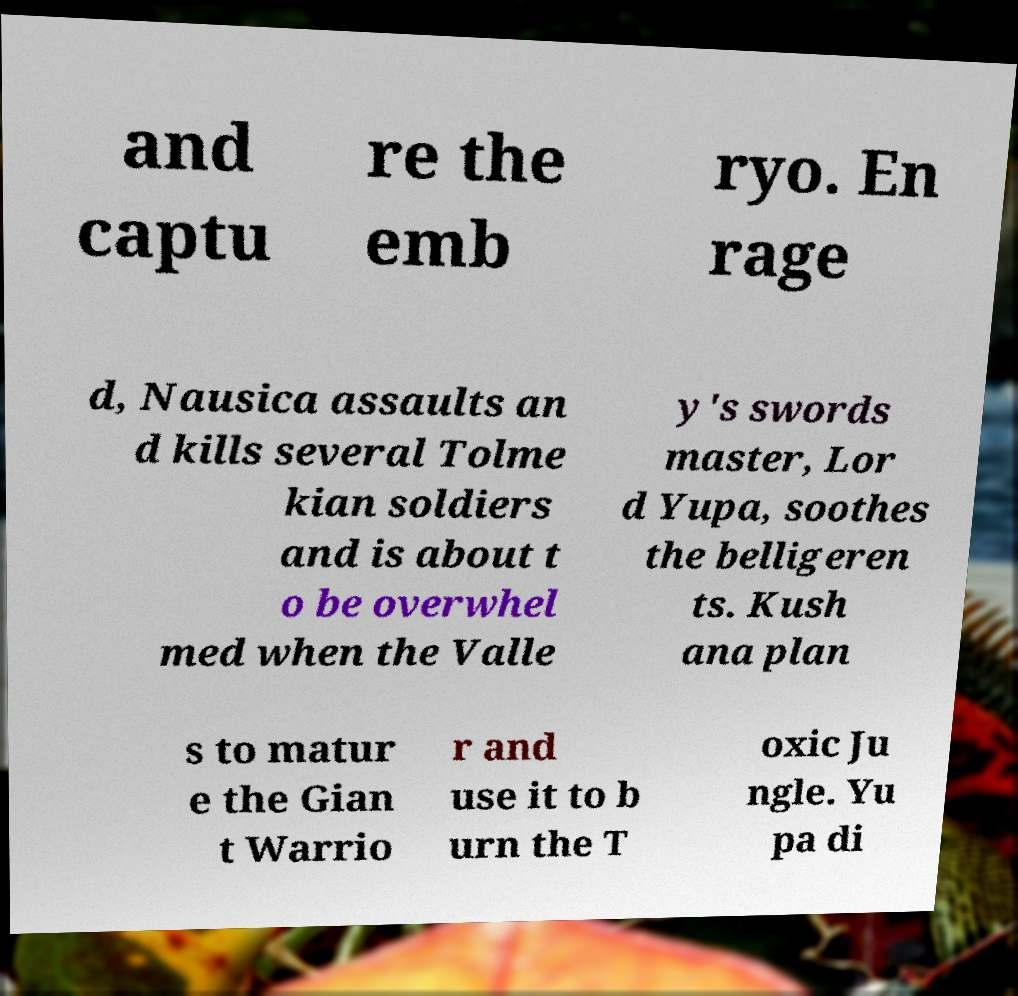Can you accurately transcribe the text from the provided image for me? and captu re the emb ryo. En rage d, Nausica assaults an d kills several Tolme kian soldiers and is about t o be overwhel med when the Valle y's swords master, Lor d Yupa, soothes the belligeren ts. Kush ana plan s to matur e the Gian t Warrio r and use it to b urn the T oxic Ju ngle. Yu pa di 